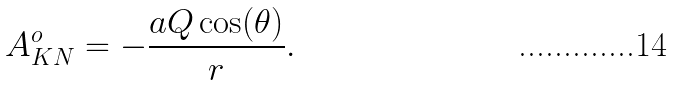Convert formula to latex. <formula><loc_0><loc_0><loc_500><loc_500>A ^ { o } _ { K N } = - \frac { a Q \cos ( \theta ) } { r } .</formula> 